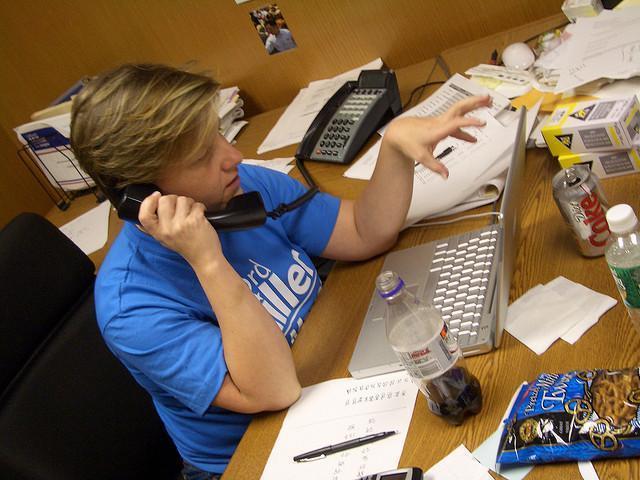How many bottles are on this desk?
Give a very brief answer. 2. How many bottles can be seen?
Give a very brief answer. 2. How many people are there?
Give a very brief answer. 1. How many books are visible?
Give a very brief answer. 2. How many giraffes are pictured?
Give a very brief answer. 0. 